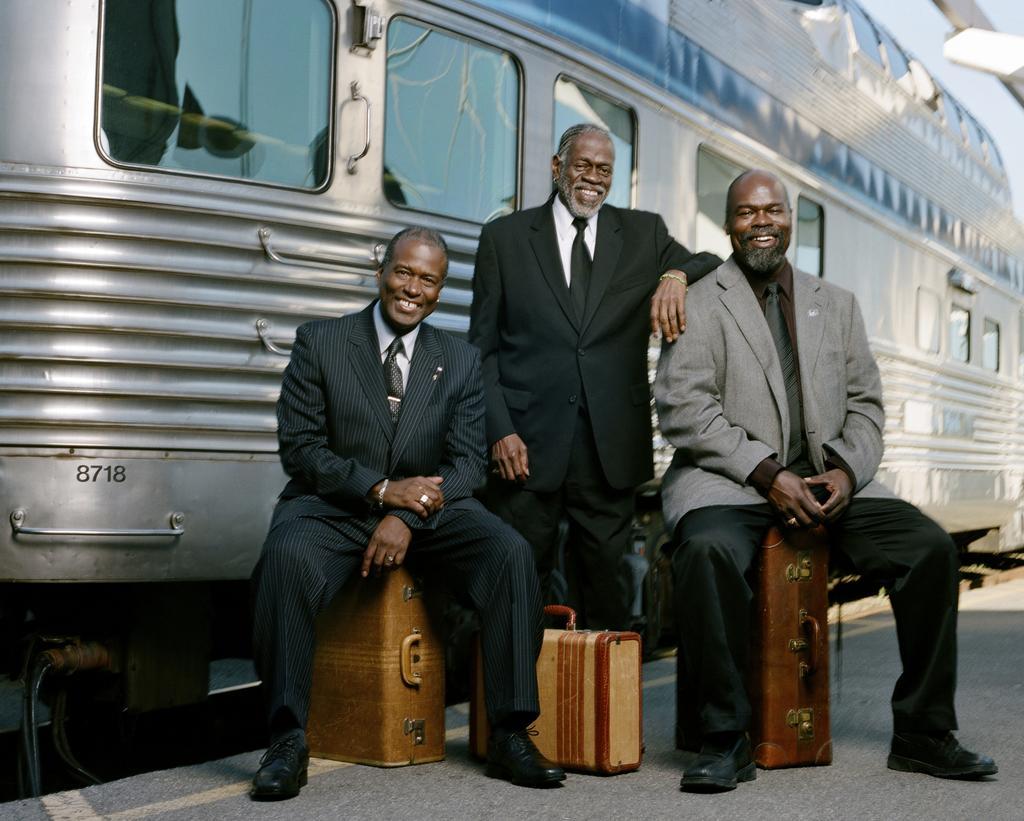Can you describe this image briefly? In the picture we can see three men, two are sitting on the suitcases and one man is standing and near to him we can see suitcase on the path and they are smiling and they are in blazers, ties, and shirts and behind them we can see a train which is gray in color with glass windows. 